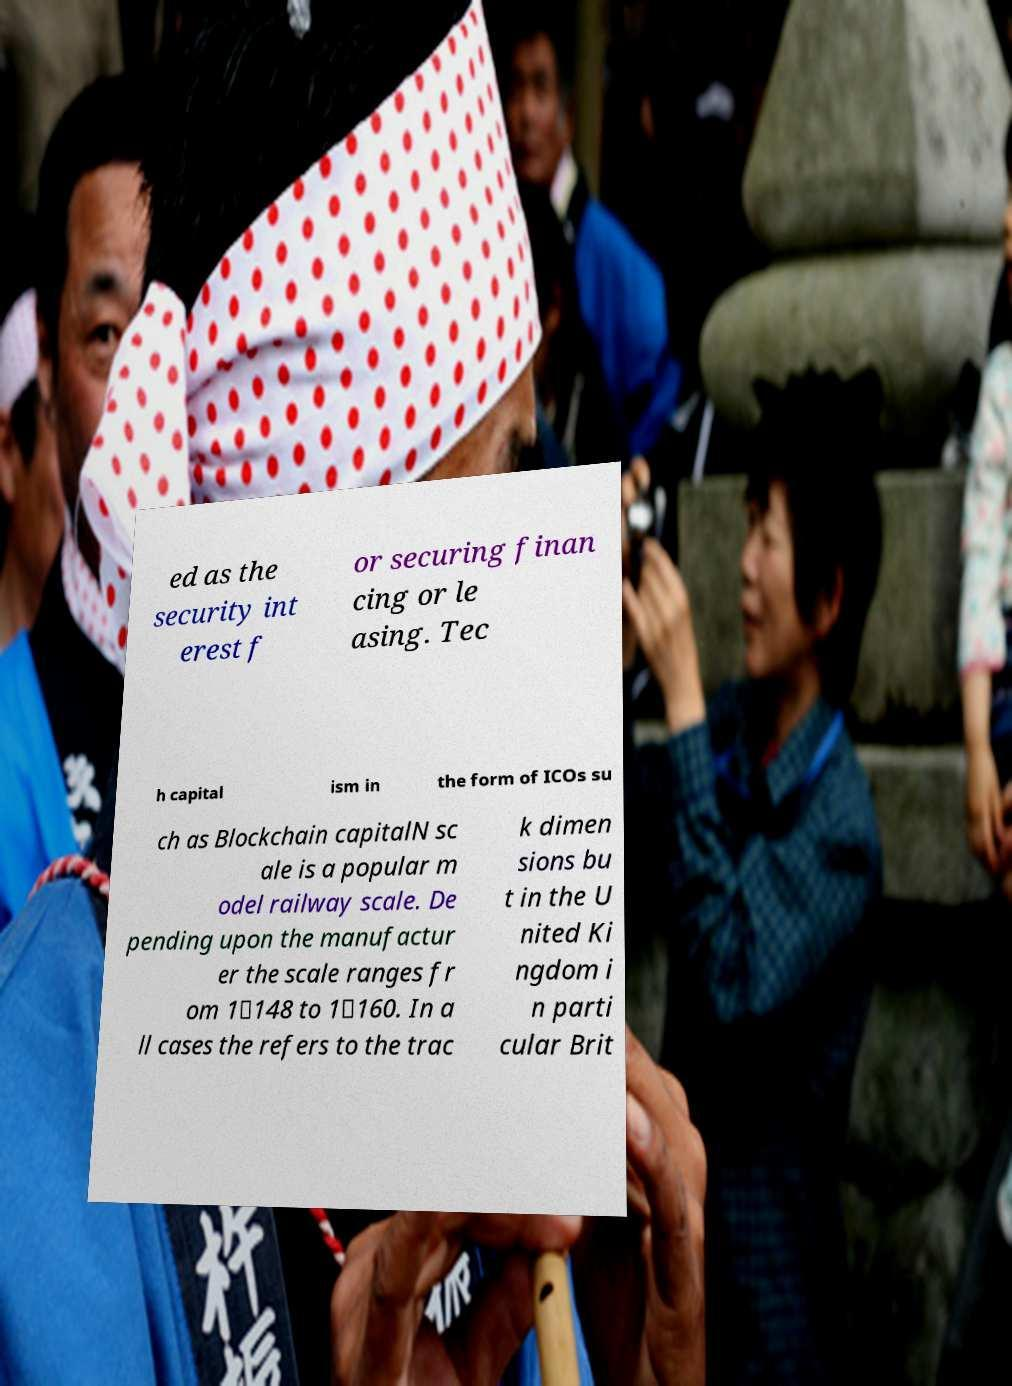For documentation purposes, I need the text within this image transcribed. Could you provide that? ed as the security int erest f or securing finan cing or le asing. Tec h capital ism in the form of ICOs su ch as Blockchain capitalN sc ale is a popular m odel railway scale. De pending upon the manufactur er the scale ranges fr om 1∶148 to 1∶160. In a ll cases the refers to the trac k dimen sions bu t in the U nited Ki ngdom i n parti cular Brit 